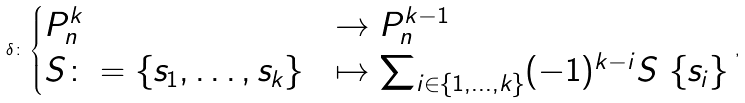Convert formula to latex. <formula><loc_0><loc_0><loc_500><loc_500>\delta \colon \begin{cases} P _ { n } ^ { k } & \to P _ { n } ^ { k - 1 } \\ S \colon = \{ s _ { 1 } , \dots , s _ { k } \} & \mapsto \sum _ { i \in \{ 1 , \dots , k \} } ( - 1 ) ^ { k - i } S \ \{ s _ { i } \} \end{cases} \, ,</formula> 